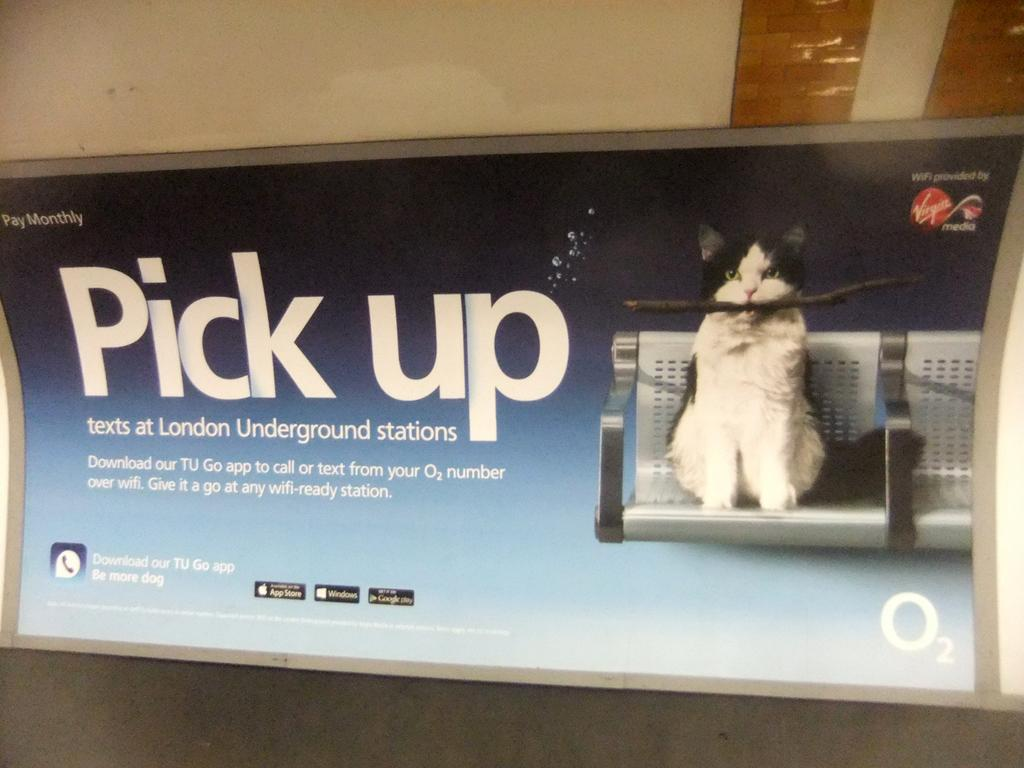What animal is present in the image? There is a cat in the image. What is the cat doing in the image? The cat is sitting on a chair. What is the cat holding in its mouth? The cat is holding a wooden piece in its mouth. What invention is the cat using to communicate with the audience in the image? There is no invention present in the image, and the cat is not communicating with an audience. How many feet does the cat have in the image? Cats have four feet, but the number of feet is not directly visible in the image. 